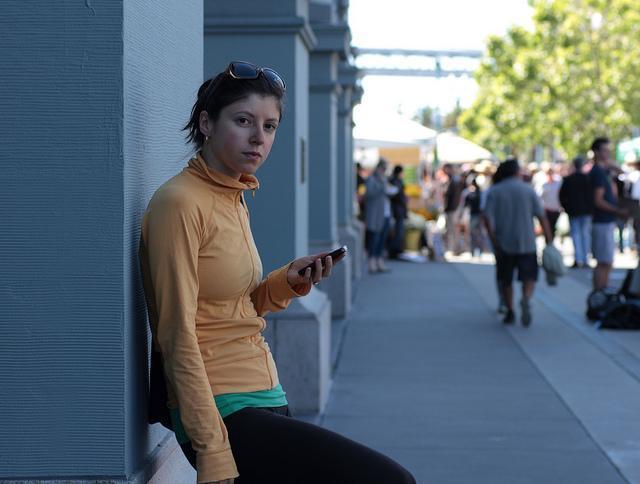How many people are in the picture?
Give a very brief answer. 5. 